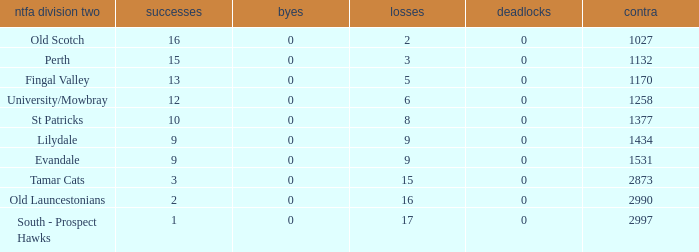What is the lowest number of draws of the NTFA Div 2 Lilydale? 0.0. 